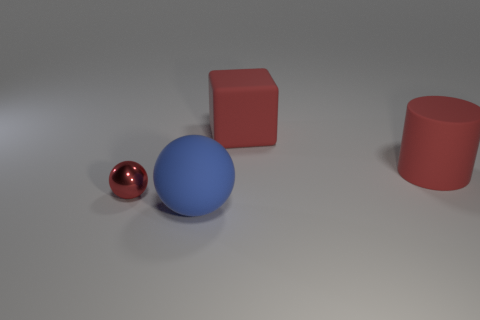What size is the sphere in front of the ball behind the sphere to the right of the tiny sphere?
Your response must be concise. Large. Is the shape of the metallic object the same as the blue rubber thing?
Make the answer very short. Yes. There is a rubber thing that is both in front of the large red cube and behind the big blue object; what size is it?
Offer a very short reply. Large. There is another blue object that is the same shape as the tiny metallic thing; what is it made of?
Give a very brief answer. Rubber. What material is the big cylinder that is right of the red thing that is on the left side of the large blue object?
Your response must be concise. Rubber. Does the blue matte object have the same shape as the big red thing in front of the rubber cube?
Your answer should be compact. No. What number of matte things are either large red spheres or blocks?
Your answer should be very brief. 1. What color is the big object left of the rubber thing that is behind the object right of the red rubber block?
Your response must be concise. Blue. How many other things are there of the same material as the tiny ball?
Keep it short and to the point. 0. Does the red object that is to the left of the blue rubber sphere have the same shape as the large blue object?
Give a very brief answer. Yes. 